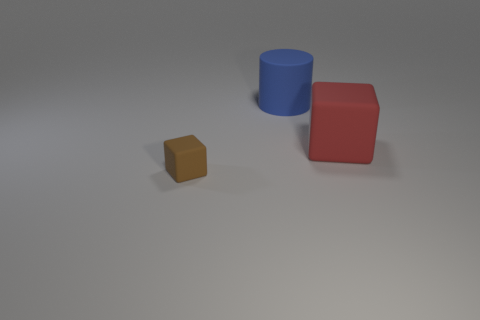Is there anything else that is the same size as the brown matte cube?
Keep it short and to the point. No. How many matte objects are in front of the thing behind the rubber block behind the brown thing?
Provide a succinct answer. 2. What is the thing that is behind the tiny cube and on the left side of the red rubber object made of?
Your answer should be very brief. Rubber. The big block has what color?
Offer a terse response. Red. Is the number of tiny brown blocks that are in front of the red object greater than the number of large matte cylinders that are left of the big cylinder?
Your answer should be very brief. Yes. The block that is behind the small rubber block is what color?
Provide a short and direct response. Red. Does the object behind the red cube have the same size as the matte thing that is on the left side of the blue object?
Your response must be concise. No. How many objects are big yellow things or cylinders?
Your response must be concise. 1. The big object that is in front of the big thing to the left of the big red rubber thing is made of what material?
Offer a very short reply. Rubber. What number of other tiny matte things have the same shape as the blue rubber thing?
Ensure brevity in your answer.  0. 